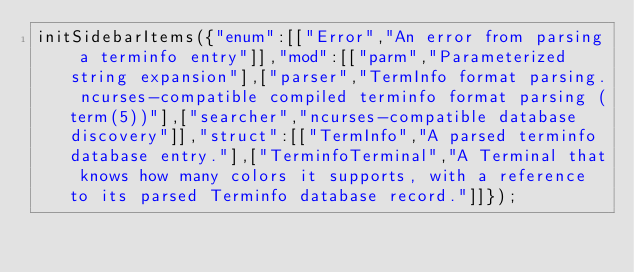Convert code to text. <code><loc_0><loc_0><loc_500><loc_500><_JavaScript_>initSidebarItems({"enum":[["Error","An error from parsing a terminfo entry"]],"mod":[["parm","Parameterized string expansion"],["parser","TermInfo format parsing. ncurses-compatible compiled terminfo format parsing (term(5))"],["searcher","ncurses-compatible database discovery"]],"struct":[["TermInfo","A parsed terminfo database entry."],["TerminfoTerminal","A Terminal that knows how many colors it supports, with a reference to its parsed Terminfo database record."]]});</code> 